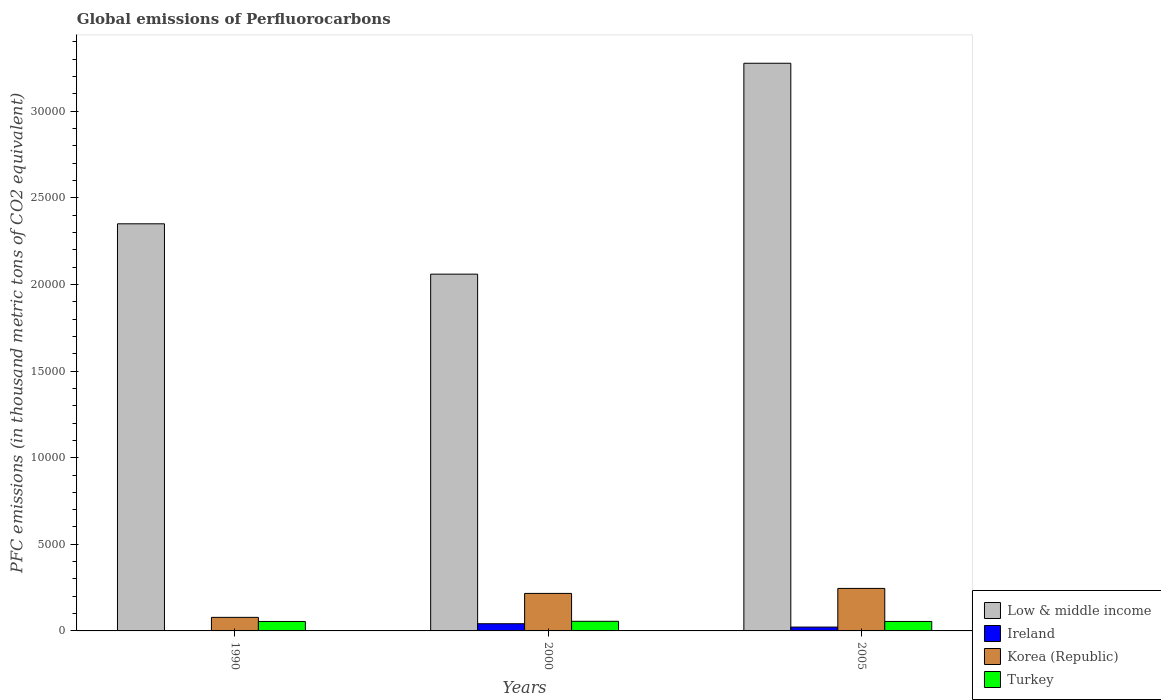How many different coloured bars are there?
Keep it short and to the point. 4. Are the number of bars per tick equal to the number of legend labels?
Provide a short and direct response. Yes. How many bars are there on the 3rd tick from the left?
Your answer should be compact. 4. What is the global emissions of Perfluorocarbons in Low & middle income in 2000?
Your response must be concise. 2.06e+04. Across all years, what is the maximum global emissions of Perfluorocarbons in Turkey?
Provide a short and direct response. 554.9. Across all years, what is the minimum global emissions of Perfluorocarbons in Korea (Republic)?
Keep it short and to the point. 782.6. What is the total global emissions of Perfluorocarbons in Ireland in the graph?
Keep it short and to the point. 638.8. What is the difference between the global emissions of Perfluorocarbons in Ireland in 1990 and that in 2005?
Your answer should be very brief. -220.4. What is the difference between the global emissions of Perfluorocarbons in Korea (Republic) in 2005 and the global emissions of Perfluorocarbons in Ireland in 1990?
Ensure brevity in your answer.  2452.3. What is the average global emissions of Perfluorocarbons in Turkey per year?
Your answer should be compact. 548.8. In the year 2005, what is the difference between the global emissions of Perfluorocarbons in Ireland and global emissions of Perfluorocarbons in Turkey?
Ensure brevity in your answer.  -324.1. In how many years, is the global emissions of Perfluorocarbons in Low & middle income greater than 26000 thousand metric tons?
Keep it short and to the point. 1. What is the ratio of the global emissions of Perfluorocarbons in Turkey in 1990 to that in 2000?
Provide a succinct answer. 0.98. Is the global emissions of Perfluorocarbons in Ireland in 1990 less than that in 2000?
Ensure brevity in your answer.  Yes. Is the difference between the global emissions of Perfluorocarbons in Ireland in 1990 and 2000 greater than the difference between the global emissions of Perfluorocarbons in Turkey in 1990 and 2000?
Ensure brevity in your answer.  No. What is the difference between the highest and the second highest global emissions of Perfluorocarbons in Korea (Republic)?
Offer a terse response. 288.8. What is the difference between the highest and the lowest global emissions of Perfluorocarbons in Low & middle income?
Offer a very short reply. 1.22e+04. Is the sum of the global emissions of Perfluorocarbons in Low & middle income in 1990 and 2000 greater than the maximum global emissions of Perfluorocarbons in Ireland across all years?
Offer a terse response. Yes. Is it the case that in every year, the sum of the global emissions of Perfluorocarbons in Korea (Republic) and global emissions of Perfluorocarbons in Low & middle income is greater than the sum of global emissions of Perfluorocarbons in Ireland and global emissions of Perfluorocarbons in Turkey?
Give a very brief answer. Yes. What does the 4th bar from the left in 2005 represents?
Your answer should be very brief. Turkey. What does the 3rd bar from the right in 1990 represents?
Make the answer very short. Ireland. How many years are there in the graph?
Ensure brevity in your answer.  3. Are the values on the major ticks of Y-axis written in scientific E-notation?
Make the answer very short. No. Does the graph contain grids?
Your response must be concise. No. What is the title of the graph?
Offer a terse response. Global emissions of Perfluorocarbons. Does "Namibia" appear as one of the legend labels in the graph?
Provide a succinct answer. No. What is the label or title of the X-axis?
Give a very brief answer. Years. What is the label or title of the Y-axis?
Offer a terse response. PFC emissions (in thousand metric tons of CO2 equivalent). What is the PFC emissions (in thousand metric tons of CO2 equivalent) in Low & middle income in 1990?
Offer a terse response. 2.35e+04. What is the PFC emissions (in thousand metric tons of CO2 equivalent) in Ireland in 1990?
Keep it short and to the point. 1.4. What is the PFC emissions (in thousand metric tons of CO2 equivalent) in Korea (Republic) in 1990?
Give a very brief answer. 782.6. What is the PFC emissions (in thousand metric tons of CO2 equivalent) of Turkey in 1990?
Give a very brief answer. 545.6. What is the PFC emissions (in thousand metric tons of CO2 equivalent) of Low & middle income in 2000?
Provide a short and direct response. 2.06e+04. What is the PFC emissions (in thousand metric tons of CO2 equivalent) of Ireland in 2000?
Your answer should be compact. 415.6. What is the PFC emissions (in thousand metric tons of CO2 equivalent) in Korea (Republic) in 2000?
Offer a very short reply. 2164.9. What is the PFC emissions (in thousand metric tons of CO2 equivalent) of Turkey in 2000?
Your response must be concise. 554.9. What is the PFC emissions (in thousand metric tons of CO2 equivalent) of Low & middle income in 2005?
Keep it short and to the point. 3.28e+04. What is the PFC emissions (in thousand metric tons of CO2 equivalent) in Ireland in 2005?
Your answer should be compact. 221.8. What is the PFC emissions (in thousand metric tons of CO2 equivalent) of Korea (Republic) in 2005?
Offer a very short reply. 2453.7. What is the PFC emissions (in thousand metric tons of CO2 equivalent) of Turkey in 2005?
Your response must be concise. 545.9. Across all years, what is the maximum PFC emissions (in thousand metric tons of CO2 equivalent) in Low & middle income?
Make the answer very short. 3.28e+04. Across all years, what is the maximum PFC emissions (in thousand metric tons of CO2 equivalent) in Ireland?
Offer a terse response. 415.6. Across all years, what is the maximum PFC emissions (in thousand metric tons of CO2 equivalent) of Korea (Republic)?
Make the answer very short. 2453.7. Across all years, what is the maximum PFC emissions (in thousand metric tons of CO2 equivalent) in Turkey?
Keep it short and to the point. 554.9. Across all years, what is the minimum PFC emissions (in thousand metric tons of CO2 equivalent) of Low & middle income?
Keep it short and to the point. 2.06e+04. Across all years, what is the minimum PFC emissions (in thousand metric tons of CO2 equivalent) of Ireland?
Keep it short and to the point. 1.4. Across all years, what is the minimum PFC emissions (in thousand metric tons of CO2 equivalent) in Korea (Republic)?
Your answer should be very brief. 782.6. Across all years, what is the minimum PFC emissions (in thousand metric tons of CO2 equivalent) in Turkey?
Provide a succinct answer. 545.6. What is the total PFC emissions (in thousand metric tons of CO2 equivalent) in Low & middle income in the graph?
Ensure brevity in your answer.  7.69e+04. What is the total PFC emissions (in thousand metric tons of CO2 equivalent) in Ireland in the graph?
Offer a terse response. 638.8. What is the total PFC emissions (in thousand metric tons of CO2 equivalent) of Korea (Republic) in the graph?
Give a very brief answer. 5401.2. What is the total PFC emissions (in thousand metric tons of CO2 equivalent) of Turkey in the graph?
Keep it short and to the point. 1646.4. What is the difference between the PFC emissions (in thousand metric tons of CO2 equivalent) of Low & middle income in 1990 and that in 2000?
Provide a succinct answer. 2906.6. What is the difference between the PFC emissions (in thousand metric tons of CO2 equivalent) of Ireland in 1990 and that in 2000?
Your answer should be very brief. -414.2. What is the difference between the PFC emissions (in thousand metric tons of CO2 equivalent) of Korea (Republic) in 1990 and that in 2000?
Offer a terse response. -1382.3. What is the difference between the PFC emissions (in thousand metric tons of CO2 equivalent) of Low & middle income in 1990 and that in 2005?
Ensure brevity in your answer.  -9268.08. What is the difference between the PFC emissions (in thousand metric tons of CO2 equivalent) in Ireland in 1990 and that in 2005?
Provide a short and direct response. -220.4. What is the difference between the PFC emissions (in thousand metric tons of CO2 equivalent) of Korea (Republic) in 1990 and that in 2005?
Provide a succinct answer. -1671.1. What is the difference between the PFC emissions (in thousand metric tons of CO2 equivalent) of Turkey in 1990 and that in 2005?
Provide a succinct answer. -0.3. What is the difference between the PFC emissions (in thousand metric tons of CO2 equivalent) in Low & middle income in 2000 and that in 2005?
Provide a short and direct response. -1.22e+04. What is the difference between the PFC emissions (in thousand metric tons of CO2 equivalent) in Ireland in 2000 and that in 2005?
Offer a terse response. 193.8. What is the difference between the PFC emissions (in thousand metric tons of CO2 equivalent) of Korea (Republic) in 2000 and that in 2005?
Provide a short and direct response. -288.8. What is the difference between the PFC emissions (in thousand metric tons of CO2 equivalent) of Low & middle income in 1990 and the PFC emissions (in thousand metric tons of CO2 equivalent) of Ireland in 2000?
Provide a succinct answer. 2.31e+04. What is the difference between the PFC emissions (in thousand metric tons of CO2 equivalent) in Low & middle income in 1990 and the PFC emissions (in thousand metric tons of CO2 equivalent) in Korea (Republic) in 2000?
Keep it short and to the point. 2.13e+04. What is the difference between the PFC emissions (in thousand metric tons of CO2 equivalent) of Low & middle income in 1990 and the PFC emissions (in thousand metric tons of CO2 equivalent) of Turkey in 2000?
Offer a terse response. 2.29e+04. What is the difference between the PFC emissions (in thousand metric tons of CO2 equivalent) in Ireland in 1990 and the PFC emissions (in thousand metric tons of CO2 equivalent) in Korea (Republic) in 2000?
Keep it short and to the point. -2163.5. What is the difference between the PFC emissions (in thousand metric tons of CO2 equivalent) of Ireland in 1990 and the PFC emissions (in thousand metric tons of CO2 equivalent) of Turkey in 2000?
Provide a succinct answer. -553.5. What is the difference between the PFC emissions (in thousand metric tons of CO2 equivalent) in Korea (Republic) in 1990 and the PFC emissions (in thousand metric tons of CO2 equivalent) in Turkey in 2000?
Provide a short and direct response. 227.7. What is the difference between the PFC emissions (in thousand metric tons of CO2 equivalent) of Low & middle income in 1990 and the PFC emissions (in thousand metric tons of CO2 equivalent) of Ireland in 2005?
Offer a very short reply. 2.33e+04. What is the difference between the PFC emissions (in thousand metric tons of CO2 equivalent) in Low & middle income in 1990 and the PFC emissions (in thousand metric tons of CO2 equivalent) in Korea (Republic) in 2005?
Your answer should be very brief. 2.10e+04. What is the difference between the PFC emissions (in thousand metric tons of CO2 equivalent) in Low & middle income in 1990 and the PFC emissions (in thousand metric tons of CO2 equivalent) in Turkey in 2005?
Ensure brevity in your answer.  2.30e+04. What is the difference between the PFC emissions (in thousand metric tons of CO2 equivalent) of Ireland in 1990 and the PFC emissions (in thousand metric tons of CO2 equivalent) of Korea (Republic) in 2005?
Ensure brevity in your answer.  -2452.3. What is the difference between the PFC emissions (in thousand metric tons of CO2 equivalent) in Ireland in 1990 and the PFC emissions (in thousand metric tons of CO2 equivalent) in Turkey in 2005?
Offer a very short reply. -544.5. What is the difference between the PFC emissions (in thousand metric tons of CO2 equivalent) of Korea (Republic) in 1990 and the PFC emissions (in thousand metric tons of CO2 equivalent) of Turkey in 2005?
Your answer should be very brief. 236.7. What is the difference between the PFC emissions (in thousand metric tons of CO2 equivalent) of Low & middle income in 2000 and the PFC emissions (in thousand metric tons of CO2 equivalent) of Ireland in 2005?
Make the answer very short. 2.04e+04. What is the difference between the PFC emissions (in thousand metric tons of CO2 equivalent) of Low & middle income in 2000 and the PFC emissions (in thousand metric tons of CO2 equivalent) of Korea (Republic) in 2005?
Ensure brevity in your answer.  1.81e+04. What is the difference between the PFC emissions (in thousand metric tons of CO2 equivalent) in Low & middle income in 2000 and the PFC emissions (in thousand metric tons of CO2 equivalent) in Turkey in 2005?
Offer a terse response. 2.00e+04. What is the difference between the PFC emissions (in thousand metric tons of CO2 equivalent) of Ireland in 2000 and the PFC emissions (in thousand metric tons of CO2 equivalent) of Korea (Republic) in 2005?
Ensure brevity in your answer.  -2038.1. What is the difference between the PFC emissions (in thousand metric tons of CO2 equivalent) of Ireland in 2000 and the PFC emissions (in thousand metric tons of CO2 equivalent) of Turkey in 2005?
Keep it short and to the point. -130.3. What is the difference between the PFC emissions (in thousand metric tons of CO2 equivalent) in Korea (Republic) in 2000 and the PFC emissions (in thousand metric tons of CO2 equivalent) in Turkey in 2005?
Your response must be concise. 1619. What is the average PFC emissions (in thousand metric tons of CO2 equivalent) of Low & middle income per year?
Keep it short and to the point. 2.56e+04. What is the average PFC emissions (in thousand metric tons of CO2 equivalent) of Ireland per year?
Provide a succinct answer. 212.93. What is the average PFC emissions (in thousand metric tons of CO2 equivalent) of Korea (Republic) per year?
Your response must be concise. 1800.4. What is the average PFC emissions (in thousand metric tons of CO2 equivalent) of Turkey per year?
Offer a very short reply. 548.8. In the year 1990, what is the difference between the PFC emissions (in thousand metric tons of CO2 equivalent) in Low & middle income and PFC emissions (in thousand metric tons of CO2 equivalent) in Ireland?
Your response must be concise. 2.35e+04. In the year 1990, what is the difference between the PFC emissions (in thousand metric tons of CO2 equivalent) in Low & middle income and PFC emissions (in thousand metric tons of CO2 equivalent) in Korea (Republic)?
Make the answer very short. 2.27e+04. In the year 1990, what is the difference between the PFC emissions (in thousand metric tons of CO2 equivalent) in Low & middle income and PFC emissions (in thousand metric tons of CO2 equivalent) in Turkey?
Provide a succinct answer. 2.30e+04. In the year 1990, what is the difference between the PFC emissions (in thousand metric tons of CO2 equivalent) in Ireland and PFC emissions (in thousand metric tons of CO2 equivalent) in Korea (Republic)?
Ensure brevity in your answer.  -781.2. In the year 1990, what is the difference between the PFC emissions (in thousand metric tons of CO2 equivalent) of Ireland and PFC emissions (in thousand metric tons of CO2 equivalent) of Turkey?
Keep it short and to the point. -544.2. In the year 1990, what is the difference between the PFC emissions (in thousand metric tons of CO2 equivalent) of Korea (Republic) and PFC emissions (in thousand metric tons of CO2 equivalent) of Turkey?
Your response must be concise. 237. In the year 2000, what is the difference between the PFC emissions (in thousand metric tons of CO2 equivalent) in Low & middle income and PFC emissions (in thousand metric tons of CO2 equivalent) in Ireland?
Ensure brevity in your answer.  2.02e+04. In the year 2000, what is the difference between the PFC emissions (in thousand metric tons of CO2 equivalent) in Low & middle income and PFC emissions (in thousand metric tons of CO2 equivalent) in Korea (Republic)?
Your answer should be very brief. 1.84e+04. In the year 2000, what is the difference between the PFC emissions (in thousand metric tons of CO2 equivalent) of Low & middle income and PFC emissions (in thousand metric tons of CO2 equivalent) of Turkey?
Ensure brevity in your answer.  2.00e+04. In the year 2000, what is the difference between the PFC emissions (in thousand metric tons of CO2 equivalent) in Ireland and PFC emissions (in thousand metric tons of CO2 equivalent) in Korea (Republic)?
Your answer should be very brief. -1749.3. In the year 2000, what is the difference between the PFC emissions (in thousand metric tons of CO2 equivalent) of Ireland and PFC emissions (in thousand metric tons of CO2 equivalent) of Turkey?
Keep it short and to the point. -139.3. In the year 2000, what is the difference between the PFC emissions (in thousand metric tons of CO2 equivalent) in Korea (Republic) and PFC emissions (in thousand metric tons of CO2 equivalent) in Turkey?
Your response must be concise. 1610. In the year 2005, what is the difference between the PFC emissions (in thousand metric tons of CO2 equivalent) in Low & middle income and PFC emissions (in thousand metric tons of CO2 equivalent) in Ireland?
Provide a short and direct response. 3.25e+04. In the year 2005, what is the difference between the PFC emissions (in thousand metric tons of CO2 equivalent) of Low & middle income and PFC emissions (in thousand metric tons of CO2 equivalent) of Korea (Republic)?
Keep it short and to the point. 3.03e+04. In the year 2005, what is the difference between the PFC emissions (in thousand metric tons of CO2 equivalent) in Low & middle income and PFC emissions (in thousand metric tons of CO2 equivalent) in Turkey?
Keep it short and to the point. 3.22e+04. In the year 2005, what is the difference between the PFC emissions (in thousand metric tons of CO2 equivalent) in Ireland and PFC emissions (in thousand metric tons of CO2 equivalent) in Korea (Republic)?
Give a very brief answer. -2231.9. In the year 2005, what is the difference between the PFC emissions (in thousand metric tons of CO2 equivalent) of Ireland and PFC emissions (in thousand metric tons of CO2 equivalent) of Turkey?
Provide a short and direct response. -324.1. In the year 2005, what is the difference between the PFC emissions (in thousand metric tons of CO2 equivalent) of Korea (Republic) and PFC emissions (in thousand metric tons of CO2 equivalent) of Turkey?
Offer a terse response. 1907.8. What is the ratio of the PFC emissions (in thousand metric tons of CO2 equivalent) in Low & middle income in 1990 to that in 2000?
Ensure brevity in your answer.  1.14. What is the ratio of the PFC emissions (in thousand metric tons of CO2 equivalent) of Ireland in 1990 to that in 2000?
Your answer should be very brief. 0. What is the ratio of the PFC emissions (in thousand metric tons of CO2 equivalent) of Korea (Republic) in 1990 to that in 2000?
Keep it short and to the point. 0.36. What is the ratio of the PFC emissions (in thousand metric tons of CO2 equivalent) in Turkey in 1990 to that in 2000?
Ensure brevity in your answer.  0.98. What is the ratio of the PFC emissions (in thousand metric tons of CO2 equivalent) of Low & middle income in 1990 to that in 2005?
Offer a terse response. 0.72. What is the ratio of the PFC emissions (in thousand metric tons of CO2 equivalent) of Ireland in 1990 to that in 2005?
Offer a terse response. 0.01. What is the ratio of the PFC emissions (in thousand metric tons of CO2 equivalent) in Korea (Republic) in 1990 to that in 2005?
Make the answer very short. 0.32. What is the ratio of the PFC emissions (in thousand metric tons of CO2 equivalent) in Low & middle income in 2000 to that in 2005?
Offer a very short reply. 0.63. What is the ratio of the PFC emissions (in thousand metric tons of CO2 equivalent) of Ireland in 2000 to that in 2005?
Offer a very short reply. 1.87. What is the ratio of the PFC emissions (in thousand metric tons of CO2 equivalent) of Korea (Republic) in 2000 to that in 2005?
Provide a succinct answer. 0.88. What is the ratio of the PFC emissions (in thousand metric tons of CO2 equivalent) of Turkey in 2000 to that in 2005?
Provide a succinct answer. 1.02. What is the difference between the highest and the second highest PFC emissions (in thousand metric tons of CO2 equivalent) of Low & middle income?
Your answer should be compact. 9268.08. What is the difference between the highest and the second highest PFC emissions (in thousand metric tons of CO2 equivalent) in Ireland?
Ensure brevity in your answer.  193.8. What is the difference between the highest and the second highest PFC emissions (in thousand metric tons of CO2 equivalent) in Korea (Republic)?
Your response must be concise. 288.8. What is the difference between the highest and the second highest PFC emissions (in thousand metric tons of CO2 equivalent) in Turkey?
Offer a terse response. 9. What is the difference between the highest and the lowest PFC emissions (in thousand metric tons of CO2 equivalent) in Low & middle income?
Provide a short and direct response. 1.22e+04. What is the difference between the highest and the lowest PFC emissions (in thousand metric tons of CO2 equivalent) of Ireland?
Ensure brevity in your answer.  414.2. What is the difference between the highest and the lowest PFC emissions (in thousand metric tons of CO2 equivalent) of Korea (Republic)?
Your answer should be very brief. 1671.1. 